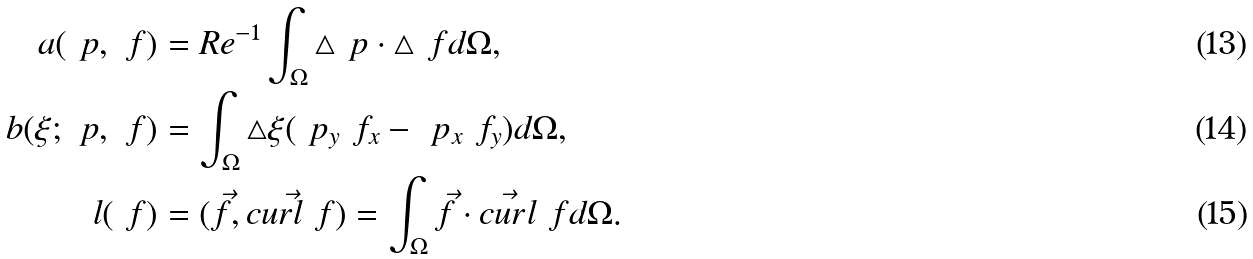Convert formula to latex. <formula><loc_0><loc_0><loc_500><loc_500>a ( \ p , \ f ) & = R e ^ { - 1 } \int _ { \Omega } \bigtriangleup \ p \cdot \bigtriangleup \ f d \Omega , \\ b ( \xi ; \ p , \ f ) & = \int _ { \Omega } \bigtriangleup \xi ( \ p _ { y } \ f _ { x } - \ p _ { x } \ f _ { y } ) d \Omega , \\ l ( \ f ) & = ( \vec { f } , \vec { c u r l \ f } ) = \int _ { \Omega } \vec { f } \cdot \vec { c u r l } \ f d \Omega .</formula> 